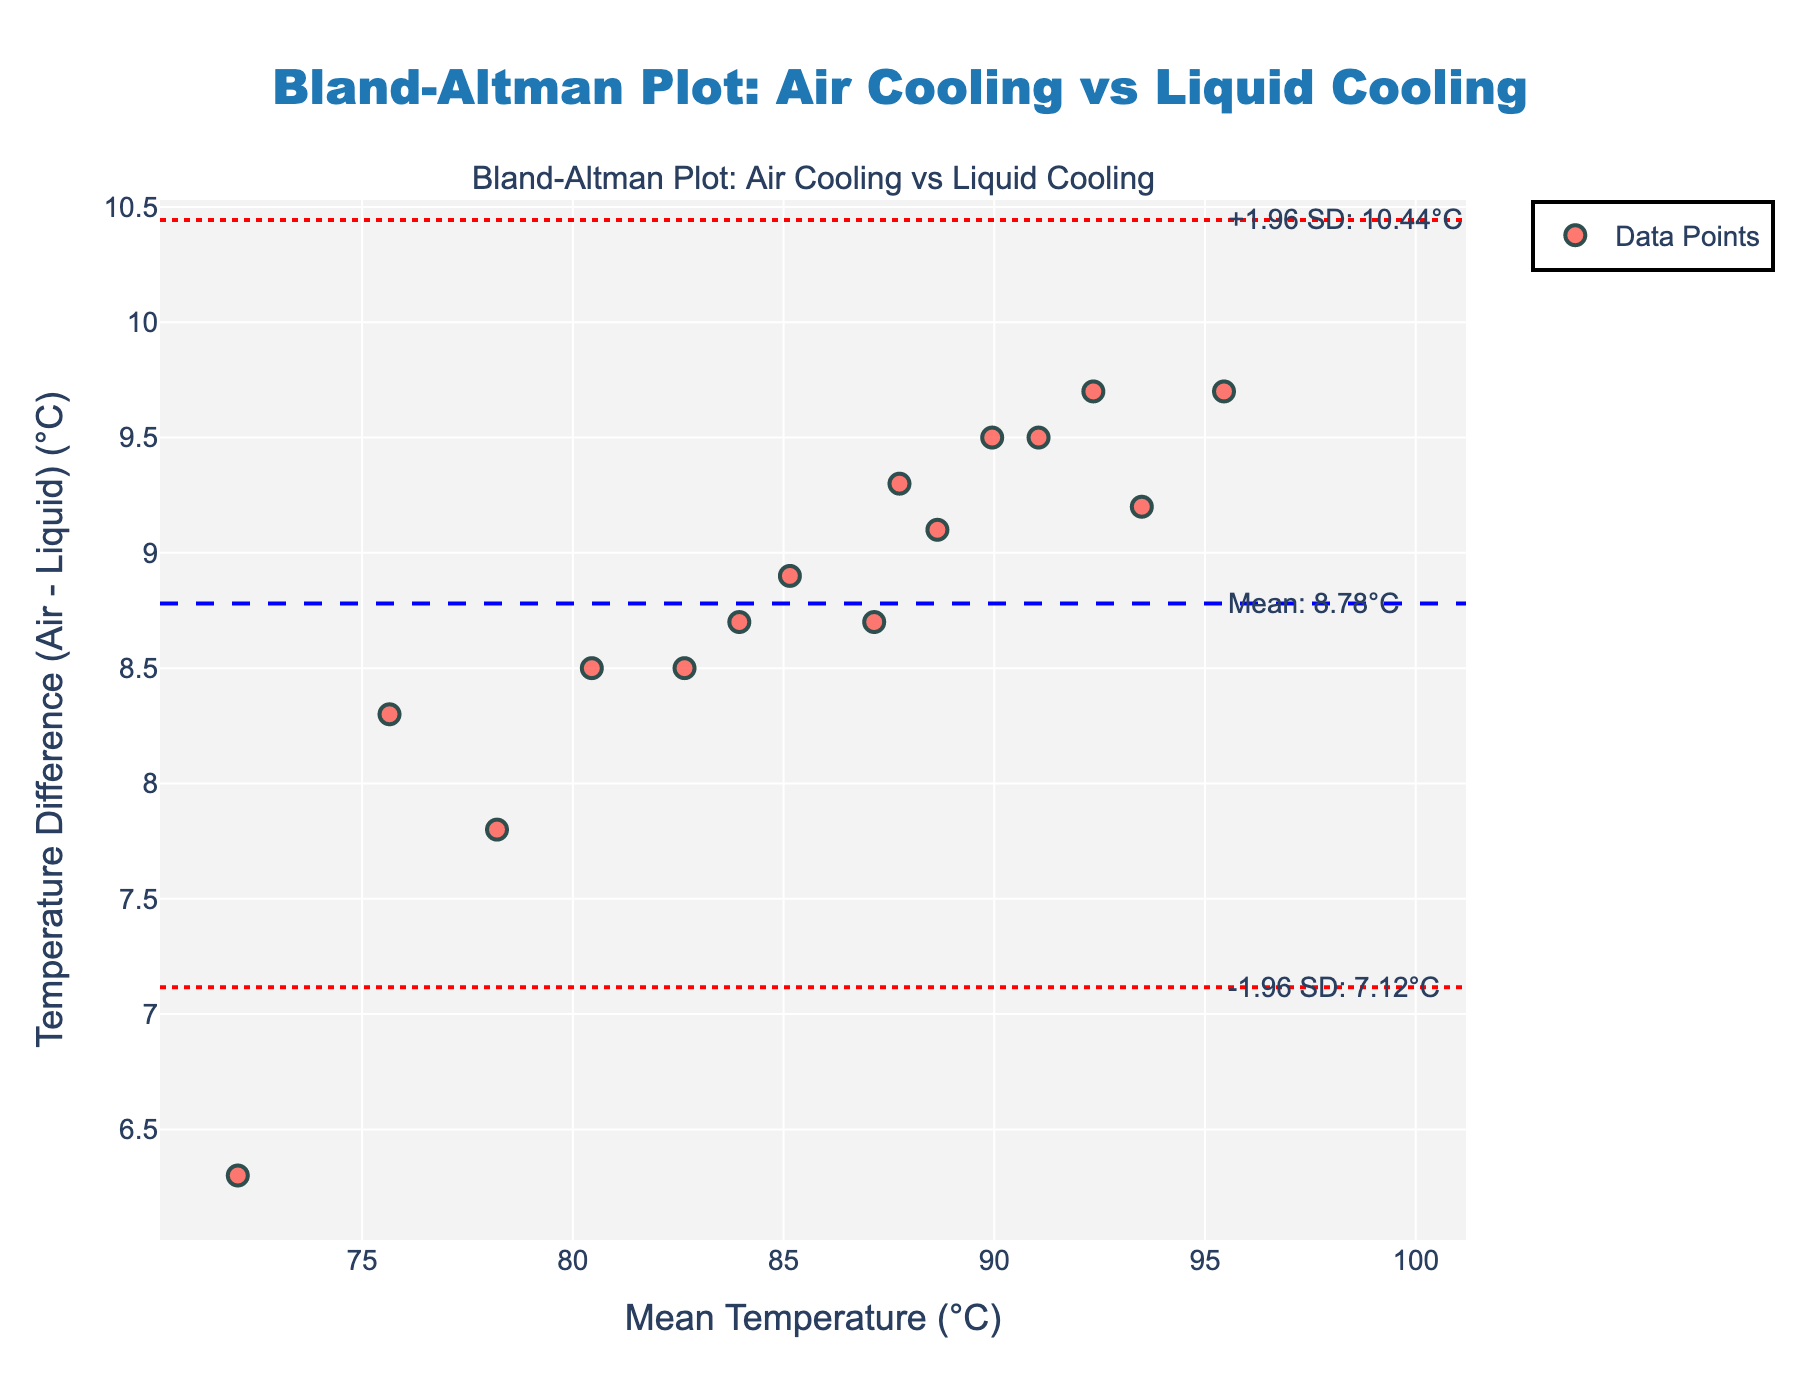What is the title of the plot? The title of the plot is at the top center of the figure. It reads "Bland-Altman Plot: Air Cooling vs Liquid Cooling".
Answer: Bland-Altman Plot: Air Cooling vs Liquid Cooling How many data points are displayed in the plot? The data points are represented by individual markers on the scatter plot. Counting each one gives a total of 15 data points.
Answer: 15 What is the y-axis title? The y-axis title is located along the vertical axis of the plot and it reads "Temperature Difference (Air - Liquid) (°C)".
Answer: Temperature Difference (Air - Liquid) (°C) According to the plot, what is the mean temperature difference between the two methods? The mean temperature difference is marked by a dashed blue line with an annotation. The annotation states "Mean: 8.80°C".
Answer: 8.80°C What are the upper and lower limits of agreement (LoA) in the plot? The upper and lower limits of agreement are represented by dotted red lines. The annotations indicate "+1.96 SD: 9.33°C" for the upper LoA and "-1.96 SD: 8.27°C" for the lower LoA.
Answer: Upper LoA: 9.33°C, Lower LoA: 8.27°C Which data point has the highest mean temperature value and what is its temperature difference? The data point with the highest mean temperature value is the farthest to the right on the x-axis. It corresponds to a mean temperature of 95.45°C and a temperature difference of 6.6°C (from the data).
Answer: Mean: 95.45°C, Temperature Difference: 6.6°C Is there a data point where the temperature difference between Air and Liquid cooling is zero? Look for a data point that lies on the dashed blue line (Mean Difference) at y=8.80°C since this would show a zero difference. There is no such point.
Answer: No Which has a greater temperature difference: a data point with a mean temperature of 83.95°C or one with 87.15°C? Check the y-values corresponding to these x-values. From the data, these points will have temperature differences of 8.7°C and 8.7°C respectively, meaning they have the same temperature difference.
Answer: Same What is the general trend of the temperature differences as the mean temperature increases? By inspecting the spread of data points, the differences tend to stay relatively constant and cluster around the mean with increasing mean temperature, showing a consistent overall difference.
Answer: Consistent overall difference What does the x-axis represent in the plot? The x-axis title is below the horizontal axis and it reads "Mean Temperature (°C)". This indicates that the x-axis represents the average temperature between both cooling methods.
Answer: Mean Temperature (°C) 